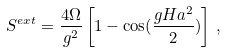Convert formula to latex. <formula><loc_0><loc_0><loc_500><loc_500>S ^ { e x t } = \frac { 4 \Omega } { g ^ { 2 } } \left [ 1 - \cos ( \frac { g H a ^ { 2 } } { 2 } ) \right ] \, ,</formula> 